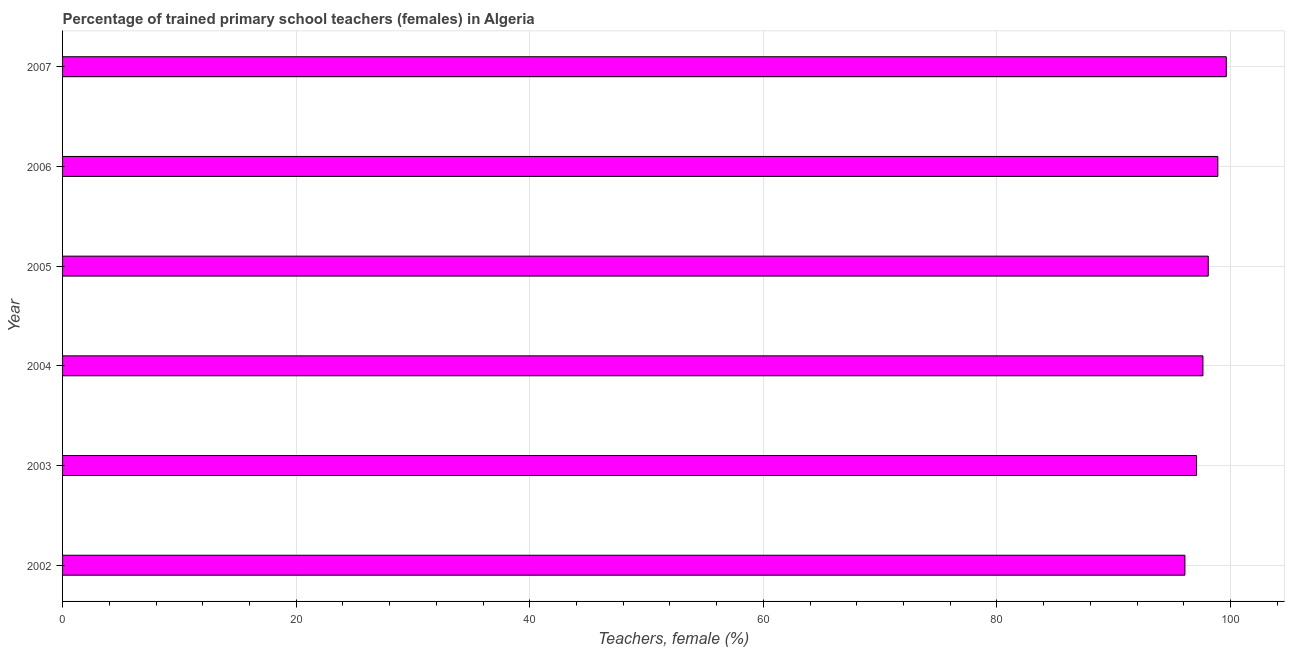Does the graph contain any zero values?
Offer a terse response. No. What is the title of the graph?
Your answer should be compact. Percentage of trained primary school teachers (females) in Algeria. What is the label or title of the X-axis?
Provide a succinct answer. Teachers, female (%). What is the percentage of trained female teachers in 2003?
Provide a short and direct response. 97.1. Across all years, what is the maximum percentage of trained female teachers?
Your answer should be very brief. 99.64. Across all years, what is the minimum percentage of trained female teachers?
Your response must be concise. 96.1. What is the sum of the percentage of trained female teachers?
Your answer should be compact. 587.49. What is the difference between the percentage of trained female teachers in 2002 and 2003?
Keep it short and to the point. -1. What is the average percentage of trained female teachers per year?
Offer a terse response. 97.92. What is the median percentage of trained female teachers?
Offer a very short reply. 97.87. Do a majority of the years between 2002 and 2004 (inclusive) have percentage of trained female teachers greater than 60 %?
Ensure brevity in your answer.  Yes. What is the ratio of the percentage of trained female teachers in 2002 to that in 2007?
Provide a short and direct response. 0.96. Is the percentage of trained female teachers in 2006 less than that in 2007?
Keep it short and to the point. Yes. Is the difference between the percentage of trained female teachers in 2003 and 2007 greater than the difference between any two years?
Make the answer very short. No. What is the difference between the highest and the second highest percentage of trained female teachers?
Your answer should be very brief. 0.72. What is the difference between the highest and the lowest percentage of trained female teachers?
Provide a succinct answer. 3.54. What is the difference between two consecutive major ticks on the X-axis?
Keep it short and to the point. 20. What is the Teachers, female (%) of 2002?
Offer a terse response. 96.1. What is the Teachers, female (%) of 2003?
Provide a succinct answer. 97.1. What is the Teachers, female (%) of 2004?
Ensure brevity in your answer.  97.64. What is the Teachers, female (%) of 2005?
Offer a terse response. 98.1. What is the Teachers, female (%) in 2006?
Offer a very short reply. 98.92. What is the Teachers, female (%) of 2007?
Provide a succinct answer. 99.64. What is the difference between the Teachers, female (%) in 2002 and 2003?
Provide a succinct answer. -1. What is the difference between the Teachers, female (%) in 2002 and 2004?
Ensure brevity in your answer.  -1.54. What is the difference between the Teachers, female (%) in 2002 and 2005?
Provide a succinct answer. -2. What is the difference between the Teachers, female (%) in 2002 and 2006?
Provide a short and direct response. -2.82. What is the difference between the Teachers, female (%) in 2002 and 2007?
Offer a terse response. -3.54. What is the difference between the Teachers, female (%) in 2003 and 2004?
Offer a very short reply. -0.54. What is the difference between the Teachers, female (%) in 2003 and 2005?
Make the answer very short. -1. What is the difference between the Teachers, female (%) in 2003 and 2006?
Your answer should be very brief. -1.82. What is the difference between the Teachers, female (%) in 2003 and 2007?
Offer a terse response. -2.55. What is the difference between the Teachers, female (%) in 2004 and 2005?
Offer a very short reply. -0.46. What is the difference between the Teachers, female (%) in 2004 and 2006?
Provide a short and direct response. -1.28. What is the difference between the Teachers, female (%) in 2004 and 2007?
Give a very brief answer. -2. What is the difference between the Teachers, female (%) in 2005 and 2006?
Offer a terse response. -0.82. What is the difference between the Teachers, female (%) in 2005 and 2007?
Ensure brevity in your answer.  -1.55. What is the difference between the Teachers, female (%) in 2006 and 2007?
Provide a short and direct response. -0.72. What is the ratio of the Teachers, female (%) in 2002 to that in 2006?
Give a very brief answer. 0.97. What is the ratio of the Teachers, female (%) in 2003 to that in 2005?
Your answer should be compact. 0.99. What is the ratio of the Teachers, female (%) in 2003 to that in 2007?
Keep it short and to the point. 0.97. What is the ratio of the Teachers, female (%) in 2004 to that in 2005?
Offer a very short reply. 0.99. What is the ratio of the Teachers, female (%) in 2004 to that in 2006?
Your response must be concise. 0.99. What is the ratio of the Teachers, female (%) in 2004 to that in 2007?
Offer a very short reply. 0.98. 